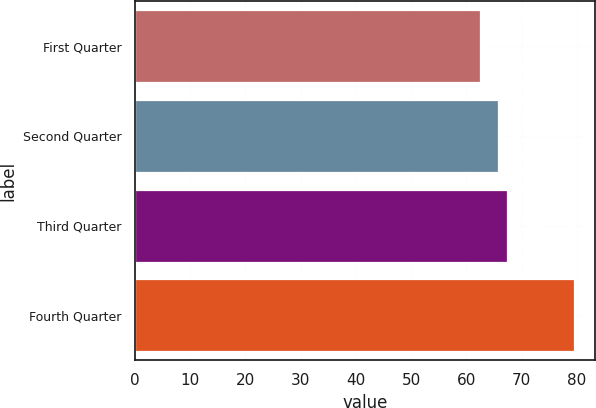<chart> <loc_0><loc_0><loc_500><loc_500><bar_chart><fcel>First Quarter<fcel>Second Quarter<fcel>Third Quarter<fcel>Fourth Quarter<nl><fcel>62.42<fcel>65.64<fcel>67.34<fcel>79.41<nl></chart> 